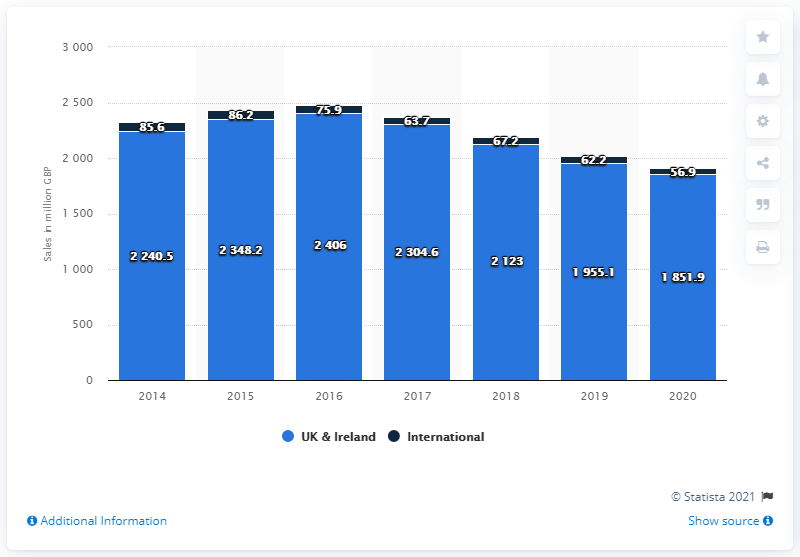Compared to its domestic performance, how did Next plc perform internationally in 2020? In 2020, as per the image's data, Next plc's international sales were £636.9 million, which is significantly lower than its UK and Ireland sales of £1,851.9 million. However, it's notable that while the UK and Ireland sales have decreased compared to the previous year, the international sales show a small increase from £622.6 million in 2019. 